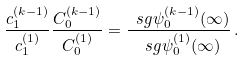<formula> <loc_0><loc_0><loc_500><loc_500>\frac { c _ { 1 } ^ { ( k - 1 ) } } { c _ { 1 } ^ { ( 1 ) } } \frac { C _ { 0 } ^ { ( k - 1 ) } } { C _ { 0 } ^ { ( 1 ) } } = \frac { \ s g { \psi _ { 0 } ^ { ( k - 1 ) } ( \infty ) } } { \ s g { \psi _ { 0 } ^ { ( 1 ) } ( \infty ) } } \, .</formula> 